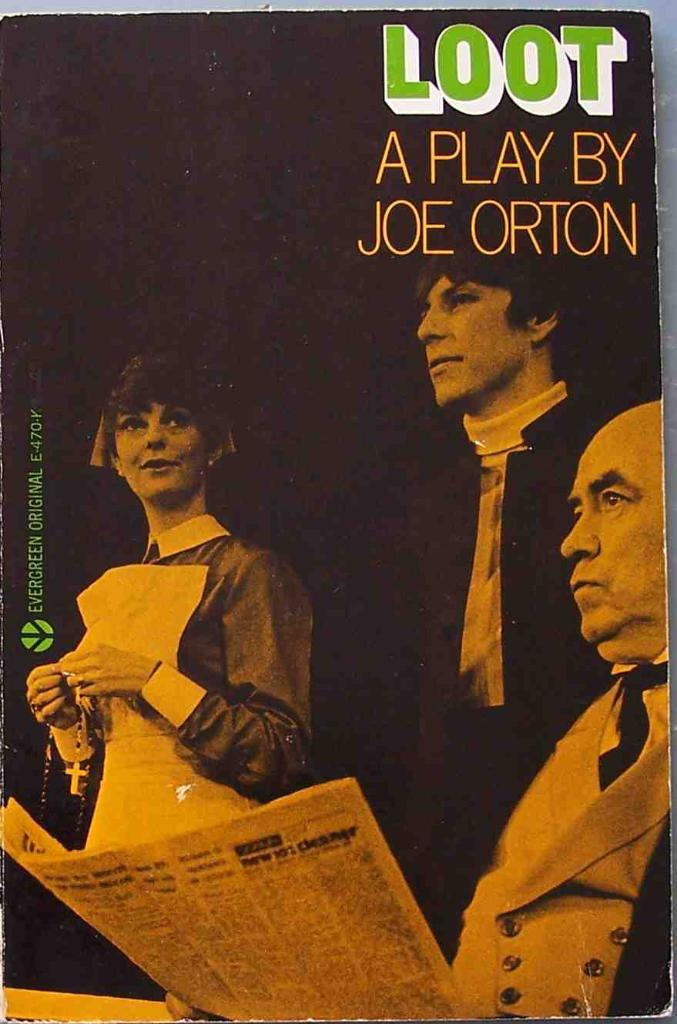<image>
Write a terse but informative summary of the picture. A playbill for Loot A Play by Joe Orton shows one man reading a newspaper and a lady with a rosary. 